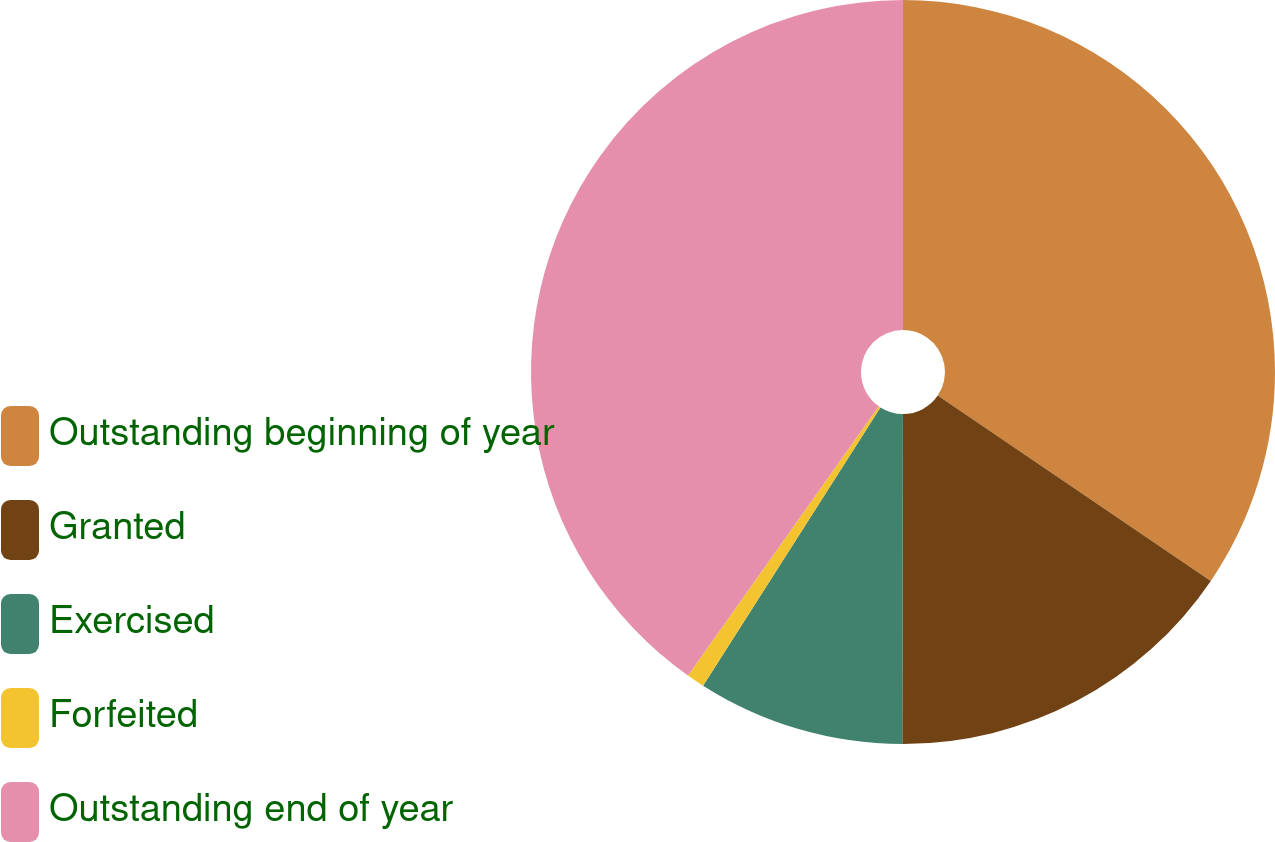Convert chart. <chart><loc_0><loc_0><loc_500><loc_500><pie_chart><fcel>Outstanding beginning of year<fcel>Granted<fcel>Exercised<fcel>Forfeited<fcel>Outstanding end of year<nl><fcel>34.49%<fcel>15.54%<fcel>9.0%<fcel>0.78%<fcel>40.19%<nl></chart> 